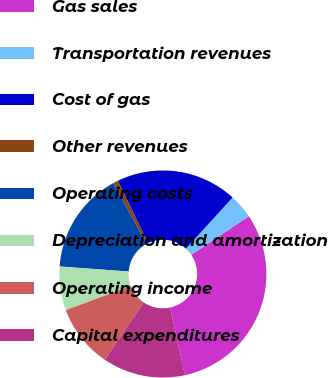<chart> <loc_0><loc_0><loc_500><loc_500><pie_chart><fcel>Gas sales<fcel>Transportation revenues<fcel>Cost of gas<fcel>Other revenues<fcel>Operating costs<fcel>Depreciation and amortization<fcel>Operating income<fcel>Capital expenditures<nl><fcel>31.01%<fcel>3.81%<fcel>18.92%<fcel>0.79%<fcel>15.9%<fcel>6.83%<fcel>9.86%<fcel>12.88%<nl></chart> 